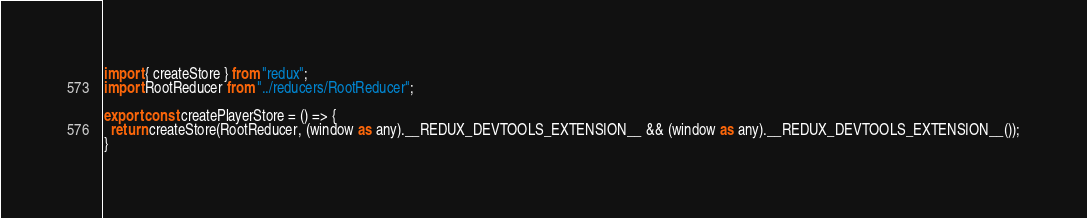<code> <loc_0><loc_0><loc_500><loc_500><_TypeScript_>import { createStore } from "redux";
import RootReducer from "../reducers/RootReducer";

export const createPlayerStore = () => {
  return createStore(RootReducer, (window as any).__REDUX_DEVTOOLS_EXTENSION__ && (window as any).__REDUX_DEVTOOLS_EXTENSION__());
}
</code> 